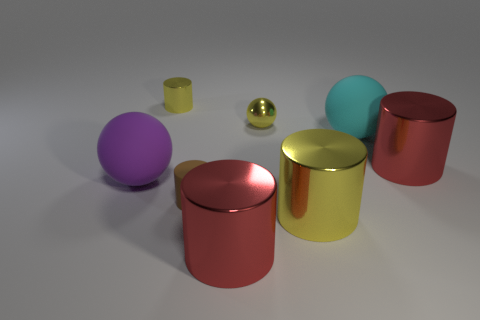There is a matte ball that is behind the large matte object that is in front of the red shiny cylinder behind the small matte cylinder; what color is it?
Provide a short and direct response. Cyan. There is a purple ball to the left of the brown cylinder left of the small sphere; what size is it?
Keep it short and to the point. Large. The cylinder that is to the right of the metallic sphere and behind the brown matte cylinder is made of what material?
Keep it short and to the point. Metal. Is the size of the cyan rubber thing the same as the yellow thing behind the small metallic sphere?
Make the answer very short. No. Is there a rubber object?
Ensure brevity in your answer.  Yes. What material is the large cyan object that is the same shape as the purple matte object?
Ensure brevity in your answer.  Rubber. How big is the sphere that is in front of the rubber thing behind the big ball that is in front of the big cyan thing?
Your answer should be very brief. Large. There is a large yellow metallic object; are there any red objects on the right side of it?
Your answer should be very brief. Yes. There is a purple object that is the same material as the tiny brown object; what is its size?
Offer a terse response. Large. What number of purple matte objects have the same shape as the cyan matte thing?
Your response must be concise. 1. 